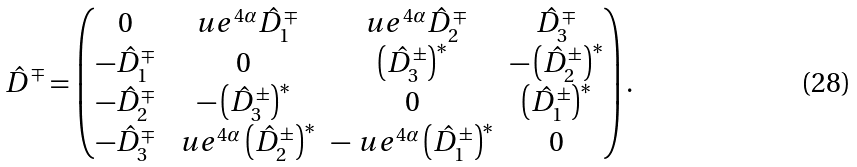<formula> <loc_0><loc_0><loc_500><loc_500>\hat { D } ^ { \mp } = \begin{pmatrix} 0 & \ u e ^ { 4 \alpha } \hat { D } ^ { \mp } _ { 1 } & \ u e ^ { 4 \alpha } \hat { D } ^ { \mp } _ { 2 } & \hat { D } ^ { \mp } _ { 3 } \\ - \hat { D } ^ { \mp } _ { 1 } & 0 & \left ( \hat { D } ^ { \pm } _ { 3 } \right ) ^ { \ast } & - \left ( \hat { D } ^ { \pm } _ { 2 } \right ) ^ { \ast } \\ - \hat { D } ^ { \mp } _ { 2 } & - \left ( \hat { D } ^ { \pm } _ { 3 } \right ) ^ { \ast } & 0 & \left ( \hat { D } ^ { \pm } _ { 1 } \right ) ^ { \ast } \\ - \hat { D } _ { 3 } ^ { \mp } & \ u e ^ { 4 \alpha } \left ( \hat { D } ^ { \pm } _ { 2 } \right ) ^ { \ast } & - \ u e ^ { 4 \alpha } \left ( \hat { D } ^ { \pm } _ { 1 } \right ) ^ { \ast } & 0 \end{pmatrix} .</formula> 